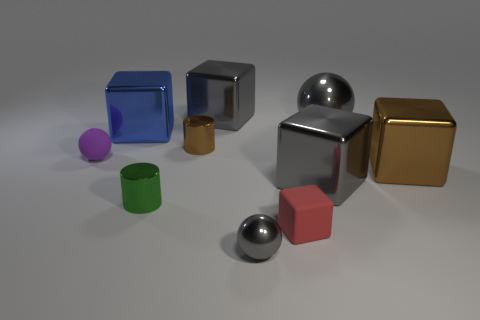Subtract all blue metallic cubes. How many cubes are left? 4 Subtract all gray balls. How many gray cubes are left? 2 Subtract all gray balls. How many balls are left? 1 Subtract 1 blocks. How many blocks are left? 4 Subtract all cylinders. How many objects are left? 8 Subtract 0 green blocks. How many objects are left? 10 Subtract all brown cylinders. Subtract all gray blocks. How many cylinders are left? 1 Subtract all small brown metallic cylinders. Subtract all tiny green things. How many objects are left? 8 Add 7 small green metal cylinders. How many small green metal cylinders are left? 8 Add 2 large blue cubes. How many large blue cubes exist? 3 